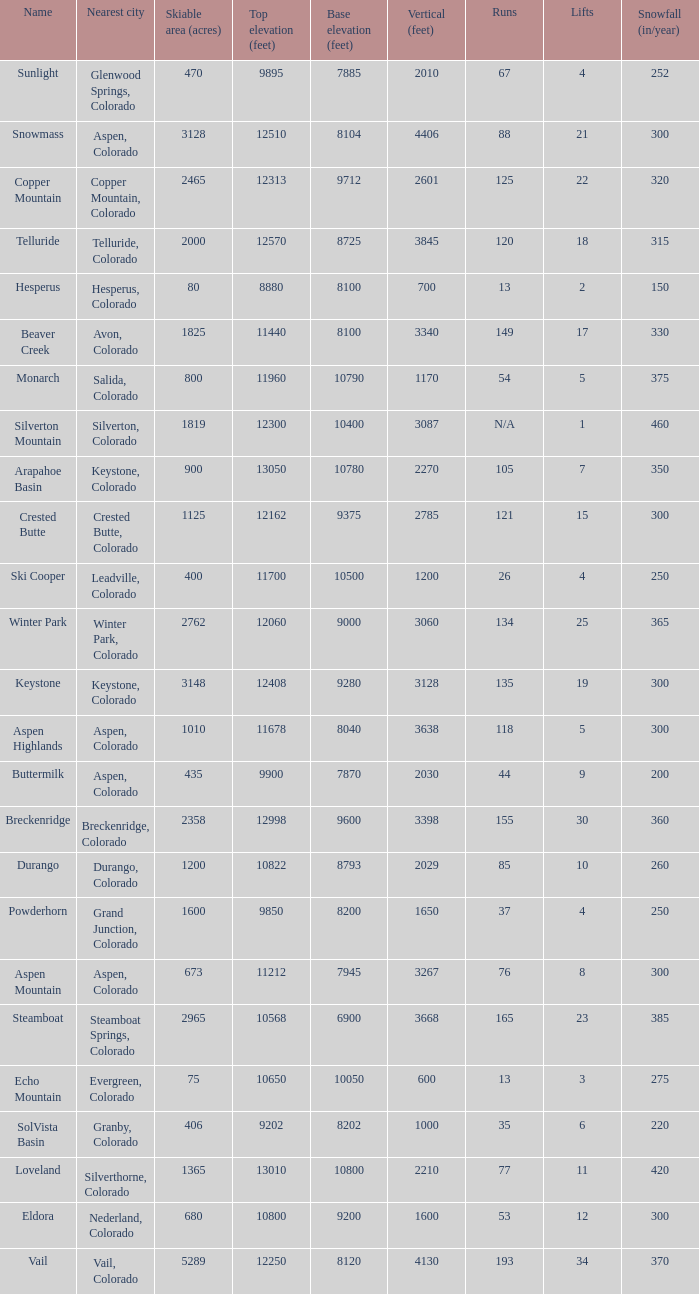If the name is Steamboat, what is the top elevation? 10568.0. 